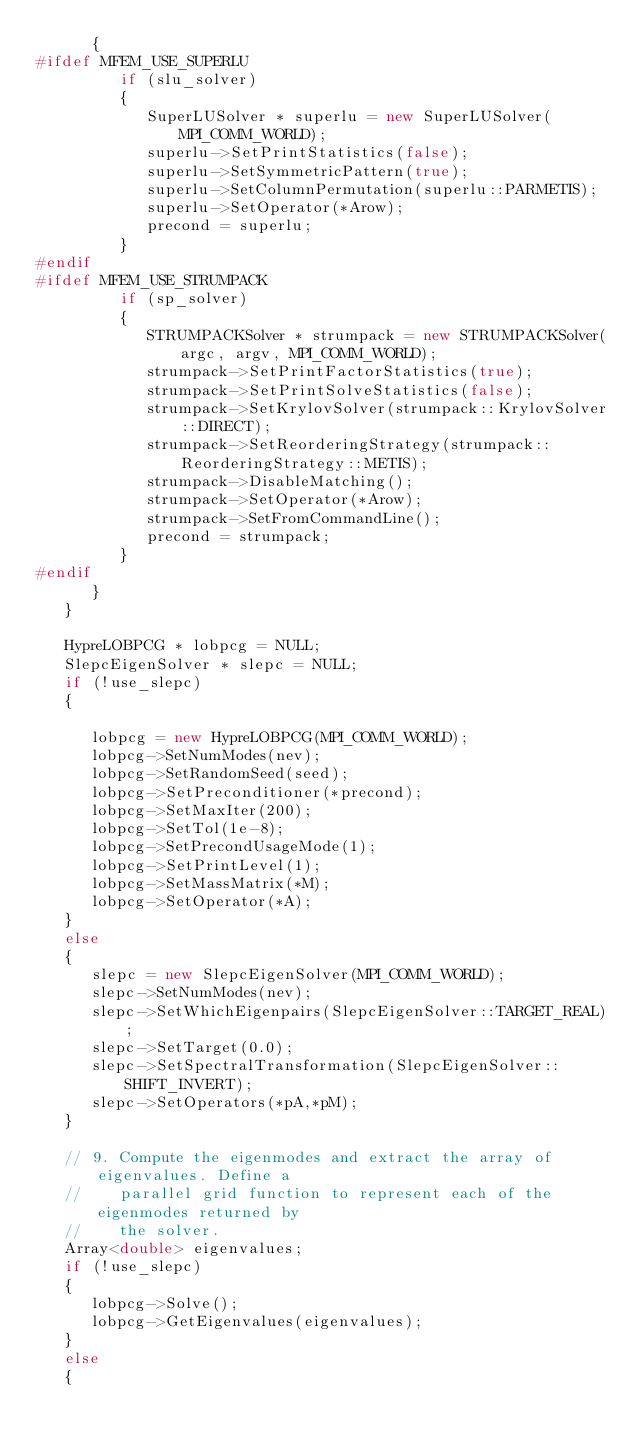<code> <loc_0><loc_0><loc_500><loc_500><_C++_>      {
#ifdef MFEM_USE_SUPERLU
         if (slu_solver)
         {
            SuperLUSolver * superlu = new SuperLUSolver(MPI_COMM_WORLD);
            superlu->SetPrintStatistics(false);
            superlu->SetSymmetricPattern(true);
            superlu->SetColumnPermutation(superlu::PARMETIS);
            superlu->SetOperator(*Arow);
            precond = superlu;
         }
#endif
#ifdef MFEM_USE_STRUMPACK
         if (sp_solver)
         {
            STRUMPACKSolver * strumpack = new STRUMPACKSolver(argc, argv, MPI_COMM_WORLD);
            strumpack->SetPrintFactorStatistics(true);
            strumpack->SetPrintSolveStatistics(false);
            strumpack->SetKrylovSolver(strumpack::KrylovSolver::DIRECT);
            strumpack->SetReorderingStrategy(strumpack::ReorderingStrategy::METIS);
            strumpack->DisableMatching();
            strumpack->SetOperator(*Arow);
            strumpack->SetFromCommandLine();
            precond = strumpack;
         }
#endif
      }
   }

   HypreLOBPCG * lobpcg = NULL;
   SlepcEigenSolver * slepc = NULL;
   if (!use_slepc)
   {

      lobpcg = new HypreLOBPCG(MPI_COMM_WORLD);
      lobpcg->SetNumModes(nev);
      lobpcg->SetRandomSeed(seed);
      lobpcg->SetPreconditioner(*precond);
      lobpcg->SetMaxIter(200);
      lobpcg->SetTol(1e-8);
      lobpcg->SetPrecondUsageMode(1);
      lobpcg->SetPrintLevel(1);
      lobpcg->SetMassMatrix(*M);
      lobpcg->SetOperator(*A);
   }
   else
   {
      slepc = new SlepcEigenSolver(MPI_COMM_WORLD);
      slepc->SetNumModes(nev);
      slepc->SetWhichEigenpairs(SlepcEigenSolver::TARGET_REAL);
      slepc->SetTarget(0.0);
      slepc->SetSpectralTransformation(SlepcEigenSolver::SHIFT_INVERT);
      slepc->SetOperators(*pA,*pM);
   }

   // 9. Compute the eigenmodes and extract the array of eigenvalues. Define a
   //    parallel grid function to represent each of the eigenmodes returned by
   //    the solver.
   Array<double> eigenvalues;
   if (!use_slepc)
   {
      lobpcg->Solve();
      lobpcg->GetEigenvalues(eigenvalues);
   }
   else
   {</code> 